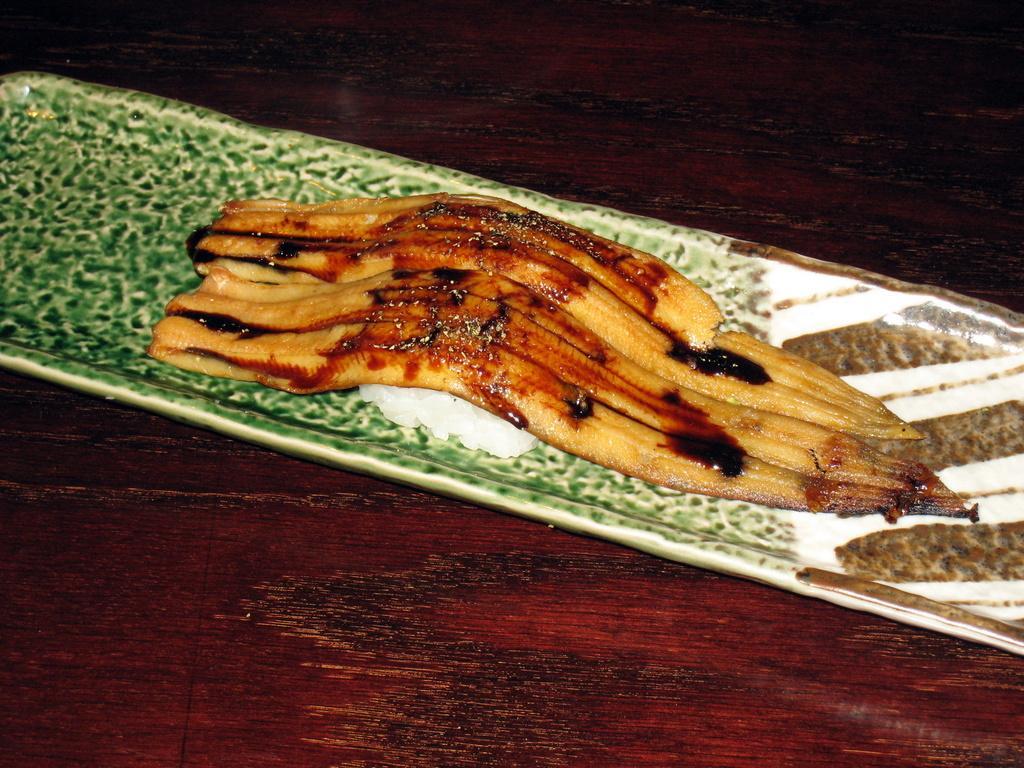In one or two sentences, can you explain what this image depicts? In this image I can see a saucer which consists of some food item. This saucer is placed on a table. 